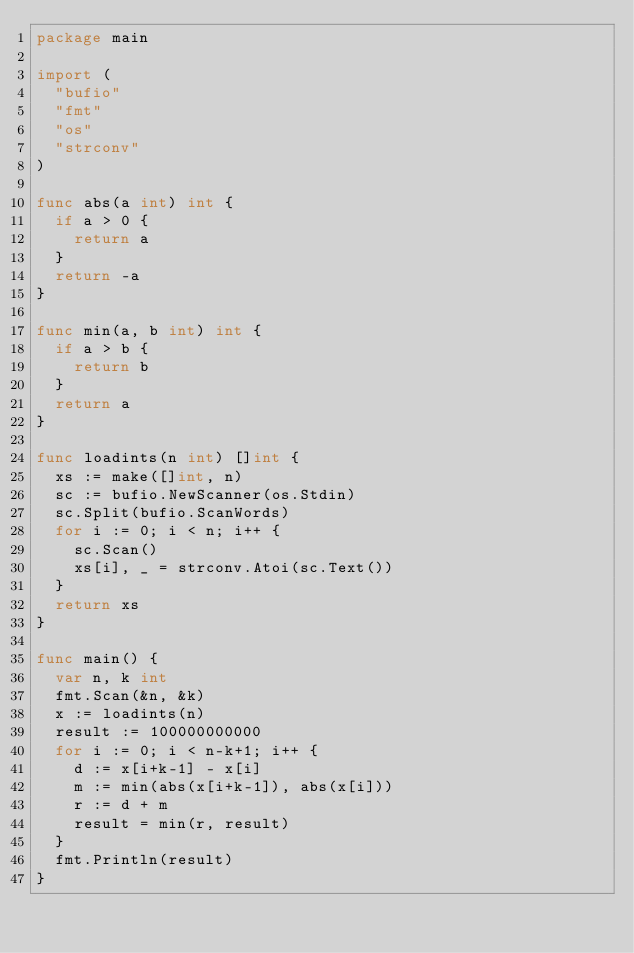Convert code to text. <code><loc_0><loc_0><loc_500><loc_500><_Go_>package main

import (
	"bufio"
	"fmt"
	"os"
	"strconv"
)

func abs(a int) int {
	if a > 0 {
		return a
	}
	return -a
}

func min(a, b int) int {
	if a > b {
		return b
	}
	return a
}

func loadints(n int) []int {
	xs := make([]int, n)
	sc := bufio.NewScanner(os.Stdin)
	sc.Split(bufio.ScanWords)
	for i := 0; i < n; i++ {
		sc.Scan()
		xs[i], _ = strconv.Atoi(sc.Text())
	}
	return xs
}

func main() {
	var n, k int
	fmt.Scan(&n, &k)
	x := loadints(n)
	result := 100000000000
	for i := 0; i < n-k+1; i++ {
		d := x[i+k-1] - x[i]
		m := min(abs(x[i+k-1]), abs(x[i]))
		r := d + m
		result = min(r, result)
	}
	fmt.Println(result)
}
</code> 